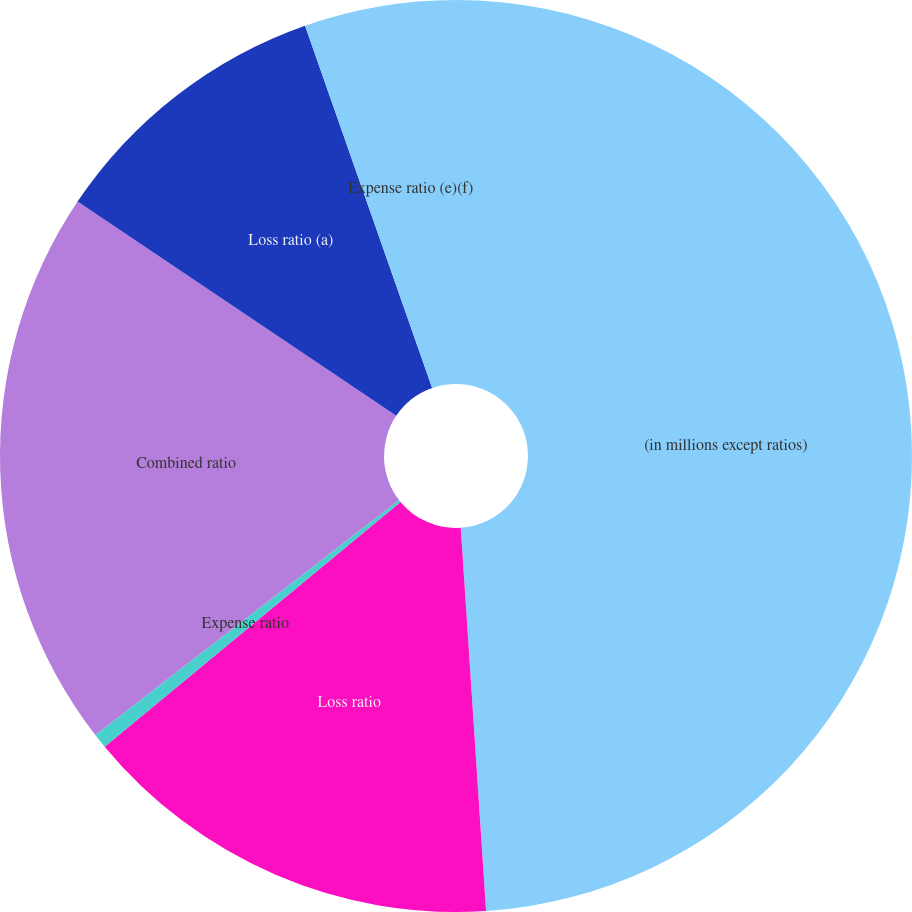<chart> <loc_0><loc_0><loc_500><loc_500><pie_chart><fcel>(in millions except ratios)<fcel>Loss ratio<fcel>Expense ratio<fcel>Combined ratio<fcel>Loss ratio (a)<fcel>Expense ratio (e)(f)<nl><fcel>48.95%<fcel>15.05%<fcel>0.52%<fcel>19.9%<fcel>10.21%<fcel>5.37%<nl></chart> 